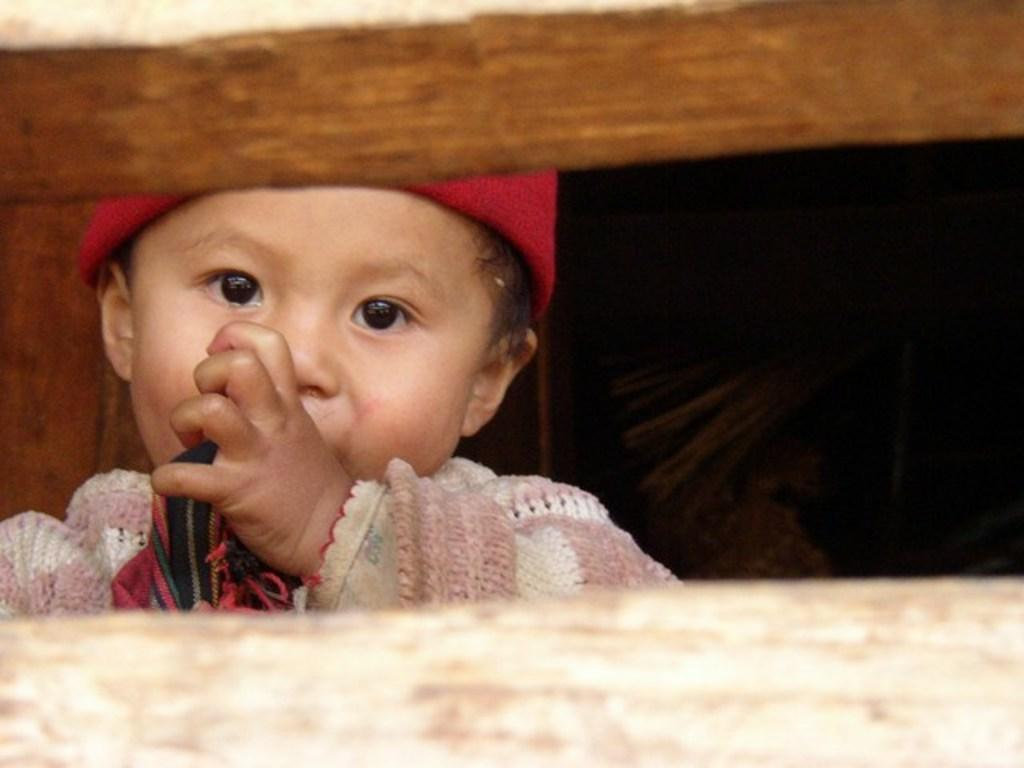Where was the image taken? The image is taken outdoors. What is the main subject in the image? There is a kid in the middle of the image. What type of clothing is the kid wearing? The kid is wearing a sweater, a scarf, and a cap. What can be seen at the bottom of the image? There is a wooden fencing at the bottom of the image. What type of jeans is the kid wearing in the image? There is no mention of jeans in the provided facts, so we cannot determine what type of jeans the kid is wearing. 